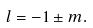<formula> <loc_0><loc_0><loc_500><loc_500>l = - 1 \pm m .</formula> 